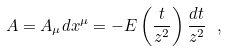<formula> <loc_0><loc_0><loc_500><loc_500>A = A _ { \mu } d x ^ { \mu } = - E \left ( \frac { t } { z ^ { 2 } } \right ) \frac { d t } { z ^ { 2 } } \ ,</formula> 